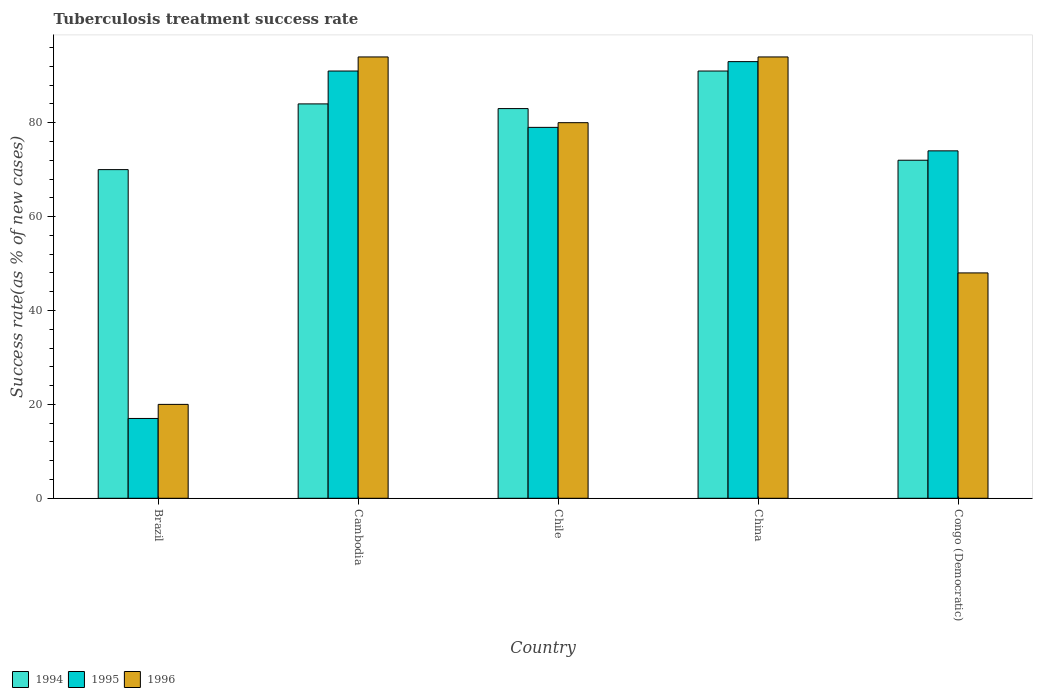How many different coloured bars are there?
Provide a short and direct response. 3. How many bars are there on the 1st tick from the left?
Ensure brevity in your answer.  3. What is the label of the 5th group of bars from the left?
Provide a short and direct response. Congo (Democratic). What is the tuberculosis treatment success rate in 1995 in Cambodia?
Your response must be concise. 91. Across all countries, what is the maximum tuberculosis treatment success rate in 1995?
Provide a succinct answer. 93. In which country was the tuberculosis treatment success rate in 1996 minimum?
Your answer should be compact. Brazil. What is the total tuberculosis treatment success rate in 1994 in the graph?
Your response must be concise. 400. What is the difference between the tuberculosis treatment success rate in 1994 in Cambodia and that in Congo (Democratic)?
Your response must be concise. 12. What is the average tuberculosis treatment success rate in 1996 per country?
Offer a terse response. 67.2. What is the difference between the tuberculosis treatment success rate of/in 1994 and tuberculosis treatment success rate of/in 1995 in China?
Your response must be concise. -2. In how many countries, is the tuberculosis treatment success rate in 1995 greater than 28 %?
Your answer should be very brief. 4. What is the ratio of the tuberculosis treatment success rate in 1996 in Cambodia to that in Congo (Democratic)?
Give a very brief answer. 1.96. Is the tuberculosis treatment success rate in 1995 in Brazil less than that in China?
Offer a very short reply. Yes. What is the difference between the highest and the lowest tuberculosis treatment success rate in 1995?
Offer a very short reply. 76. Is the sum of the tuberculosis treatment success rate in 1995 in Brazil and Chile greater than the maximum tuberculosis treatment success rate in 1996 across all countries?
Your answer should be compact. Yes. Is it the case that in every country, the sum of the tuberculosis treatment success rate in 1995 and tuberculosis treatment success rate in 1996 is greater than the tuberculosis treatment success rate in 1994?
Give a very brief answer. No. How many bars are there?
Your response must be concise. 15. Are all the bars in the graph horizontal?
Offer a terse response. No. What is the difference between two consecutive major ticks on the Y-axis?
Your response must be concise. 20. Does the graph contain any zero values?
Make the answer very short. No. Does the graph contain grids?
Make the answer very short. No. Where does the legend appear in the graph?
Your response must be concise. Bottom left. How are the legend labels stacked?
Your answer should be compact. Horizontal. What is the title of the graph?
Keep it short and to the point. Tuberculosis treatment success rate. What is the label or title of the X-axis?
Provide a short and direct response. Country. What is the label or title of the Y-axis?
Your response must be concise. Success rate(as % of new cases). What is the Success rate(as % of new cases) in 1994 in Brazil?
Offer a terse response. 70. What is the Success rate(as % of new cases) in 1994 in Cambodia?
Your response must be concise. 84. What is the Success rate(as % of new cases) of 1995 in Cambodia?
Keep it short and to the point. 91. What is the Success rate(as % of new cases) of 1996 in Cambodia?
Give a very brief answer. 94. What is the Success rate(as % of new cases) in 1995 in Chile?
Your response must be concise. 79. What is the Success rate(as % of new cases) of 1994 in China?
Give a very brief answer. 91. What is the Success rate(as % of new cases) in 1995 in China?
Give a very brief answer. 93. What is the Success rate(as % of new cases) in 1996 in China?
Ensure brevity in your answer.  94. What is the Success rate(as % of new cases) of 1994 in Congo (Democratic)?
Your answer should be compact. 72. What is the Success rate(as % of new cases) of 1995 in Congo (Democratic)?
Provide a short and direct response. 74. Across all countries, what is the maximum Success rate(as % of new cases) in 1994?
Give a very brief answer. 91. Across all countries, what is the maximum Success rate(as % of new cases) in 1995?
Give a very brief answer. 93. Across all countries, what is the maximum Success rate(as % of new cases) in 1996?
Give a very brief answer. 94. Across all countries, what is the minimum Success rate(as % of new cases) in 1994?
Provide a short and direct response. 70. Across all countries, what is the minimum Success rate(as % of new cases) of 1995?
Ensure brevity in your answer.  17. What is the total Success rate(as % of new cases) of 1994 in the graph?
Ensure brevity in your answer.  400. What is the total Success rate(as % of new cases) of 1995 in the graph?
Provide a short and direct response. 354. What is the total Success rate(as % of new cases) of 1996 in the graph?
Offer a very short reply. 336. What is the difference between the Success rate(as % of new cases) in 1995 in Brazil and that in Cambodia?
Ensure brevity in your answer.  -74. What is the difference between the Success rate(as % of new cases) in 1996 in Brazil and that in Cambodia?
Keep it short and to the point. -74. What is the difference between the Success rate(as % of new cases) of 1994 in Brazil and that in Chile?
Offer a very short reply. -13. What is the difference between the Success rate(as % of new cases) of 1995 in Brazil and that in Chile?
Give a very brief answer. -62. What is the difference between the Success rate(as % of new cases) in 1996 in Brazil and that in Chile?
Keep it short and to the point. -60. What is the difference between the Success rate(as % of new cases) in 1994 in Brazil and that in China?
Your response must be concise. -21. What is the difference between the Success rate(as % of new cases) of 1995 in Brazil and that in China?
Provide a short and direct response. -76. What is the difference between the Success rate(as % of new cases) in 1996 in Brazil and that in China?
Offer a terse response. -74. What is the difference between the Success rate(as % of new cases) in 1995 in Brazil and that in Congo (Democratic)?
Your answer should be very brief. -57. What is the difference between the Success rate(as % of new cases) of 1994 in Cambodia and that in Chile?
Keep it short and to the point. 1. What is the difference between the Success rate(as % of new cases) of 1994 in Cambodia and that in China?
Your response must be concise. -7. What is the difference between the Success rate(as % of new cases) of 1996 in Cambodia and that in China?
Provide a succinct answer. 0. What is the difference between the Success rate(as % of new cases) in 1994 in Cambodia and that in Congo (Democratic)?
Provide a short and direct response. 12. What is the difference between the Success rate(as % of new cases) in 1995 in Cambodia and that in Congo (Democratic)?
Your response must be concise. 17. What is the difference between the Success rate(as % of new cases) in 1996 in Cambodia and that in Congo (Democratic)?
Your answer should be compact. 46. What is the difference between the Success rate(as % of new cases) of 1995 in Chile and that in China?
Provide a succinct answer. -14. What is the difference between the Success rate(as % of new cases) in 1996 in Chile and that in China?
Provide a short and direct response. -14. What is the difference between the Success rate(as % of new cases) in 1996 in Chile and that in Congo (Democratic)?
Your response must be concise. 32. What is the difference between the Success rate(as % of new cases) in 1995 in China and that in Congo (Democratic)?
Your answer should be compact. 19. What is the difference between the Success rate(as % of new cases) of 1996 in China and that in Congo (Democratic)?
Your answer should be compact. 46. What is the difference between the Success rate(as % of new cases) of 1994 in Brazil and the Success rate(as % of new cases) of 1996 in Cambodia?
Provide a succinct answer. -24. What is the difference between the Success rate(as % of new cases) of 1995 in Brazil and the Success rate(as % of new cases) of 1996 in Cambodia?
Ensure brevity in your answer.  -77. What is the difference between the Success rate(as % of new cases) in 1994 in Brazil and the Success rate(as % of new cases) in 1996 in Chile?
Give a very brief answer. -10. What is the difference between the Success rate(as % of new cases) of 1995 in Brazil and the Success rate(as % of new cases) of 1996 in Chile?
Your answer should be compact. -63. What is the difference between the Success rate(as % of new cases) in 1994 in Brazil and the Success rate(as % of new cases) in 1995 in China?
Give a very brief answer. -23. What is the difference between the Success rate(as % of new cases) in 1994 in Brazil and the Success rate(as % of new cases) in 1996 in China?
Make the answer very short. -24. What is the difference between the Success rate(as % of new cases) in 1995 in Brazil and the Success rate(as % of new cases) in 1996 in China?
Your response must be concise. -77. What is the difference between the Success rate(as % of new cases) of 1995 in Brazil and the Success rate(as % of new cases) of 1996 in Congo (Democratic)?
Make the answer very short. -31. What is the difference between the Success rate(as % of new cases) of 1994 in Cambodia and the Success rate(as % of new cases) of 1995 in Chile?
Ensure brevity in your answer.  5. What is the difference between the Success rate(as % of new cases) in 1994 in Cambodia and the Success rate(as % of new cases) in 1996 in Chile?
Your response must be concise. 4. What is the difference between the Success rate(as % of new cases) of 1995 in Cambodia and the Success rate(as % of new cases) of 1996 in Chile?
Provide a succinct answer. 11. What is the difference between the Success rate(as % of new cases) of 1994 in Cambodia and the Success rate(as % of new cases) of 1996 in Congo (Democratic)?
Offer a terse response. 36. What is the difference between the Success rate(as % of new cases) of 1995 in Cambodia and the Success rate(as % of new cases) of 1996 in Congo (Democratic)?
Offer a very short reply. 43. What is the difference between the Success rate(as % of new cases) of 1995 in Chile and the Success rate(as % of new cases) of 1996 in China?
Your response must be concise. -15. What is the difference between the Success rate(as % of new cases) in 1994 in Chile and the Success rate(as % of new cases) in 1996 in Congo (Democratic)?
Give a very brief answer. 35. What is the difference between the Success rate(as % of new cases) of 1995 in Chile and the Success rate(as % of new cases) of 1996 in Congo (Democratic)?
Make the answer very short. 31. What is the difference between the Success rate(as % of new cases) of 1994 in China and the Success rate(as % of new cases) of 1995 in Congo (Democratic)?
Offer a terse response. 17. What is the difference between the Success rate(as % of new cases) of 1994 in China and the Success rate(as % of new cases) of 1996 in Congo (Democratic)?
Provide a succinct answer. 43. What is the average Success rate(as % of new cases) in 1995 per country?
Keep it short and to the point. 70.8. What is the average Success rate(as % of new cases) in 1996 per country?
Provide a short and direct response. 67.2. What is the difference between the Success rate(as % of new cases) of 1994 and Success rate(as % of new cases) of 1996 in Brazil?
Your response must be concise. 50. What is the difference between the Success rate(as % of new cases) of 1994 and Success rate(as % of new cases) of 1995 in Cambodia?
Keep it short and to the point. -7. What is the difference between the Success rate(as % of new cases) of 1995 and Success rate(as % of new cases) of 1996 in Cambodia?
Keep it short and to the point. -3. What is the difference between the Success rate(as % of new cases) of 1994 and Success rate(as % of new cases) of 1995 in Chile?
Offer a very short reply. 4. What is the difference between the Success rate(as % of new cases) in 1994 and Success rate(as % of new cases) in 1996 in Chile?
Your answer should be very brief. 3. What is the difference between the Success rate(as % of new cases) of 1995 and Success rate(as % of new cases) of 1996 in Chile?
Your answer should be very brief. -1. What is the difference between the Success rate(as % of new cases) of 1995 and Success rate(as % of new cases) of 1996 in China?
Provide a succinct answer. -1. What is the difference between the Success rate(as % of new cases) of 1994 and Success rate(as % of new cases) of 1995 in Congo (Democratic)?
Your answer should be very brief. -2. What is the difference between the Success rate(as % of new cases) in 1994 and Success rate(as % of new cases) in 1996 in Congo (Democratic)?
Keep it short and to the point. 24. What is the ratio of the Success rate(as % of new cases) in 1995 in Brazil to that in Cambodia?
Your answer should be very brief. 0.19. What is the ratio of the Success rate(as % of new cases) of 1996 in Brazil to that in Cambodia?
Offer a terse response. 0.21. What is the ratio of the Success rate(as % of new cases) of 1994 in Brazil to that in Chile?
Give a very brief answer. 0.84. What is the ratio of the Success rate(as % of new cases) of 1995 in Brazil to that in Chile?
Provide a succinct answer. 0.22. What is the ratio of the Success rate(as % of new cases) of 1996 in Brazil to that in Chile?
Give a very brief answer. 0.25. What is the ratio of the Success rate(as % of new cases) of 1994 in Brazil to that in China?
Offer a very short reply. 0.77. What is the ratio of the Success rate(as % of new cases) of 1995 in Brazil to that in China?
Make the answer very short. 0.18. What is the ratio of the Success rate(as % of new cases) of 1996 in Brazil to that in China?
Your response must be concise. 0.21. What is the ratio of the Success rate(as % of new cases) in 1994 in Brazil to that in Congo (Democratic)?
Your answer should be compact. 0.97. What is the ratio of the Success rate(as % of new cases) in 1995 in Brazil to that in Congo (Democratic)?
Your answer should be compact. 0.23. What is the ratio of the Success rate(as % of new cases) of 1996 in Brazil to that in Congo (Democratic)?
Your answer should be compact. 0.42. What is the ratio of the Success rate(as % of new cases) in 1995 in Cambodia to that in Chile?
Give a very brief answer. 1.15. What is the ratio of the Success rate(as % of new cases) of 1996 in Cambodia to that in Chile?
Your answer should be very brief. 1.18. What is the ratio of the Success rate(as % of new cases) of 1995 in Cambodia to that in China?
Your response must be concise. 0.98. What is the ratio of the Success rate(as % of new cases) of 1995 in Cambodia to that in Congo (Democratic)?
Make the answer very short. 1.23. What is the ratio of the Success rate(as % of new cases) in 1996 in Cambodia to that in Congo (Democratic)?
Your answer should be compact. 1.96. What is the ratio of the Success rate(as % of new cases) in 1994 in Chile to that in China?
Provide a succinct answer. 0.91. What is the ratio of the Success rate(as % of new cases) in 1995 in Chile to that in China?
Keep it short and to the point. 0.85. What is the ratio of the Success rate(as % of new cases) of 1996 in Chile to that in China?
Your answer should be compact. 0.85. What is the ratio of the Success rate(as % of new cases) in 1994 in Chile to that in Congo (Democratic)?
Ensure brevity in your answer.  1.15. What is the ratio of the Success rate(as % of new cases) in 1995 in Chile to that in Congo (Democratic)?
Your answer should be compact. 1.07. What is the ratio of the Success rate(as % of new cases) of 1996 in Chile to that in Congo (Democratic)?
Offer a very short reply. 1.67. What is the ratio of the Success rate(as % of new cases) in 1994 in China to that in Congo (Democratic)?
Your response must be concise. 1.26. What is the ratio of the Success rate(as % of new cases) in 1995 in China to that in Congo (Democratic)?
Keep it short and to the point. 1.26. What is the ratio of the Success rate(as % of new cases) of 1996 in China to that in Congo (Democratic)?
Keep it short and to the point. 1.96. What is the difference between the highest and the lowest Success rate(as % of new cases) in 1996?
Offer a very short reply. 74. 